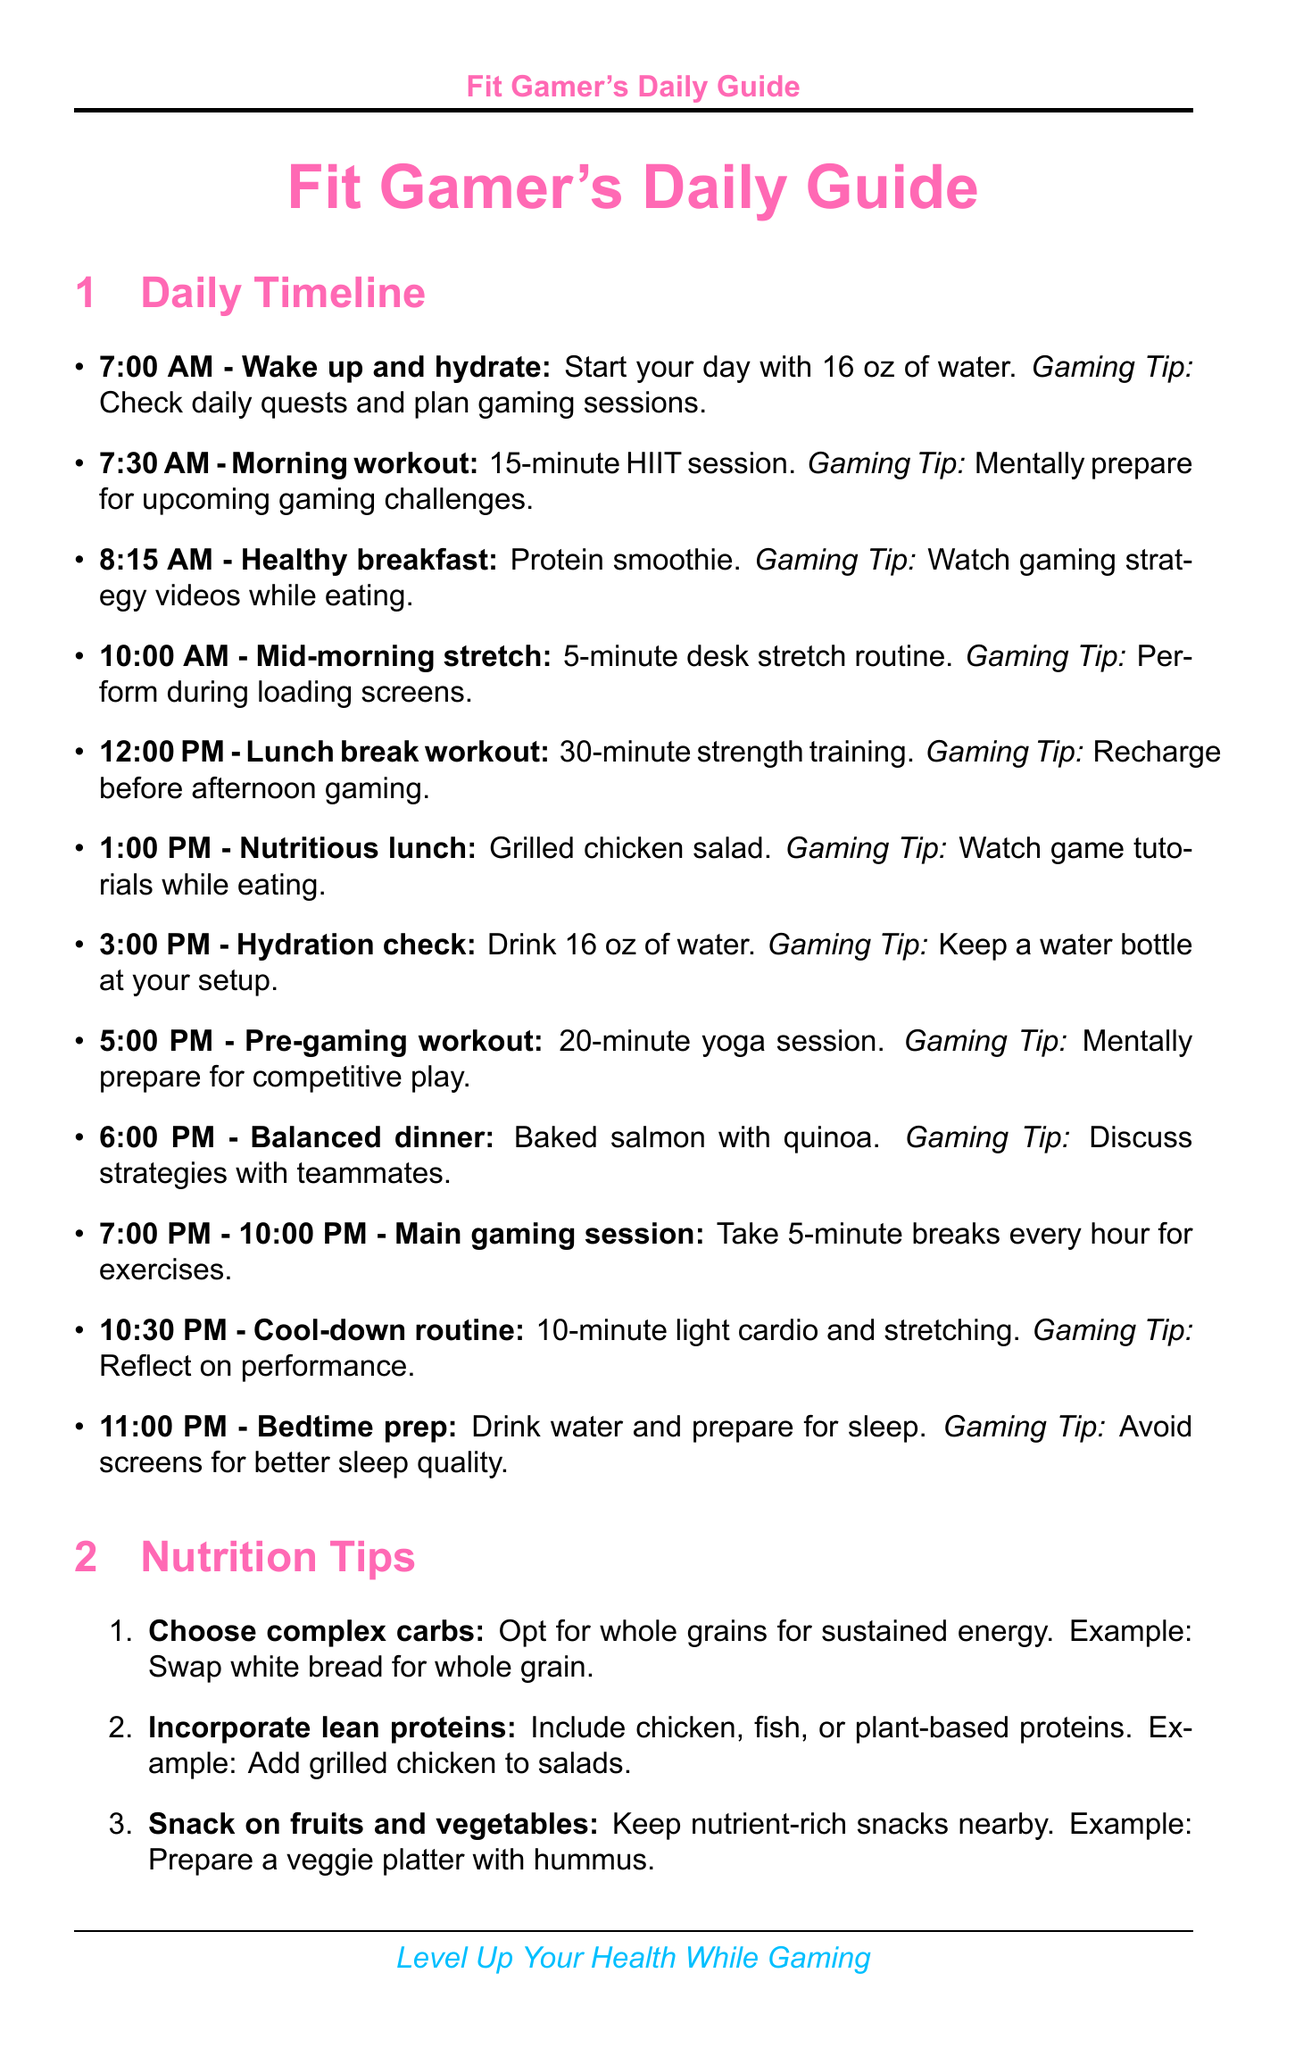What time should you wake up and hydrate? The document specifies the wake-up time and hydration activity.
Answer: 7:00 AM What type of training is suggested for lunch break? The document mentions the workout type during the lunch break.
Answer: Strength training How many ounces of water should you drink at noon? The hydration check suggests a specific amount of water to drink.
Answer: 16 oz What is the main exercise during the morning workout? The document lists the exercises included in the morning workout session.
Answer: HIIT session What is one benefit of using blue light filtering? The document explains one of the benefits related to blue light filtering.
Answer: Improves sleep quality What is a nutrient-rich snack suggestion? The document provides examples of healthy snacks to have during gaming.
Answer: Veggie platter with hummus What hydration reminder involves using apps? The document specifies an app-related hydration reminder.
Answer: Use hydration tracking apps How long should the main gaming session last? The document indicates the duration of the main gaming activity.
Answer: 3 hours (7:00 PM - 10:00 PM) 